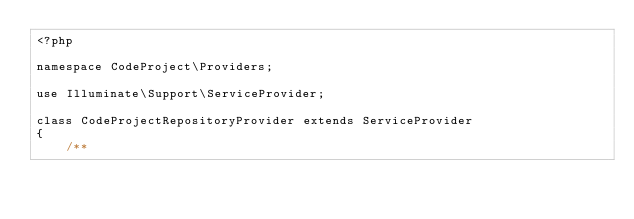Convert code to text. <code><loc_0><loc_0><loc_500><loc_500><_PHP_><?php

namespace CodeProject\Providers;

use Illuminate\Support\ServiceProvider;

class CodeProjectRepositoryProvider extends ServiceProvider
{
    /**</code> 